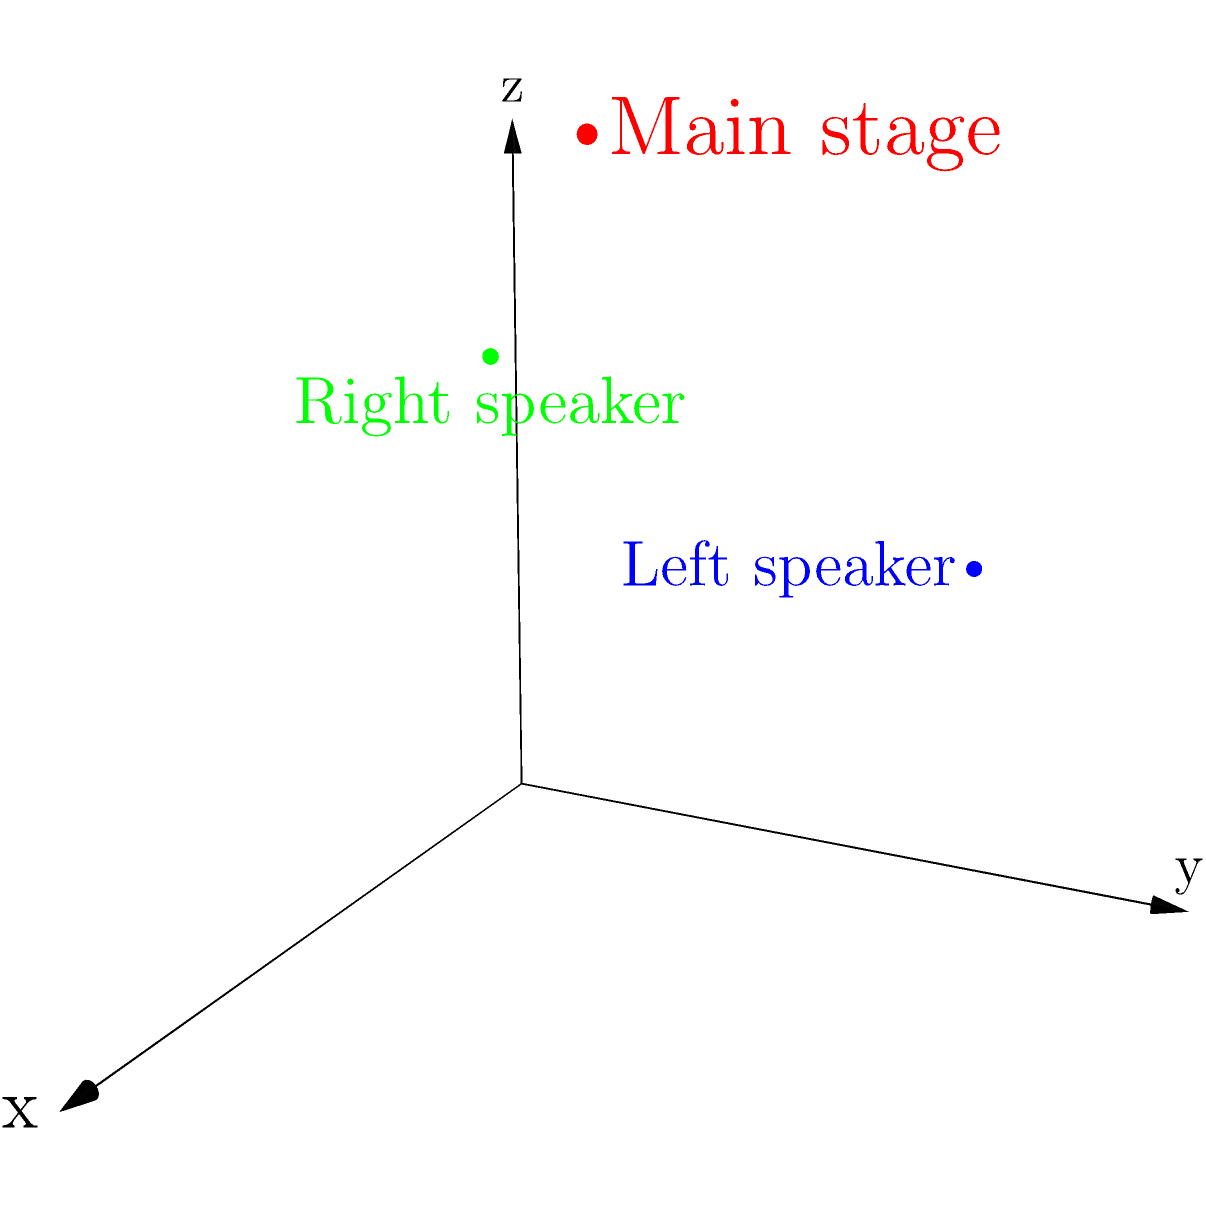In designing a concert stage layout, you've placed the main stage and two speakers in a 3D coordinate system. The main stage is at point (3,2,4), the left speaker at (1,3,2), and the right speaker at (2,1,3). What is the total distance between the left speaker and the right speaker, rounded to two decimal places? To find the distance between the left and right speakers, we can use the 3D distance formula:

$$d = \sqrt{(x_2-x_1)^2 + (y_2-y_1)^2 + (z_2-z_1)^2}$$

Where $(x_1,y_1,z_1)$ is the position of the left speaker and $(x_2,y_2,z_2)$ is the position of the right speaker.

Step 1: Identify the coordinates
Left speaker: (1,3,2)
Right speaker: (2,1,3)

Step 2: Plug the values into the formula
$$d = \sqrt{(2-1)^2 + (1-3)^2 + (3-2)^2}$$

Step 3: Calculate the differences
$$d = \sqrt{1^2 + (-2)^2 + 1^2}$$

Step 4: Square the differences
$$d = \sqrt{1 + 4 + 1}$$

Step 5: Add the squared differences
$$d = \sqrt{6}$$

Step 6: Calculate the square root and round to two decimal places
$$d \approx 2.45$$

Therefore, the distance between the left and right speakers is approximately 2.45 units.
Answer: 2.45 units 